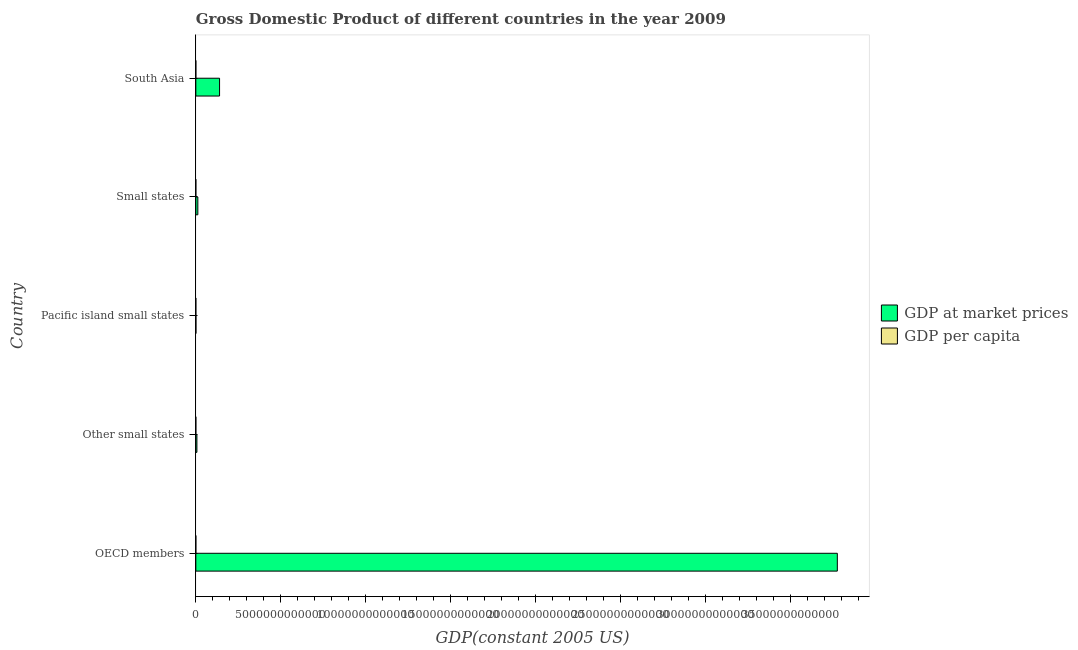How many different coloured bars are there?
Offer a terse response. 2. Are the number of bars per tick equal to the number of legend labels?
Your response must be concise. Yes. Are the number of bars on each tick of the Y-axis equal?
Offer a terse response. Yes. How many bars are there on the 1st tick from the bottom?
Keep it short and to the point. 2. What is the label of the 4th group of bars from the top?
Your answer should be compact. Other small states. What is the gdp per capita in Small states?
Give a very brief answer. 4236.76. Across all countries, what is the maximum gdp at market prices?
Ensure brevity in your answer.  3.77e+13. Across all countries, what is the minimum gdp per capita?
Give a very brief answer. 869.5. In which country was the gdp at market prices maximum?
Your answer should be very brief. OECD members. In which country was the gdp at market prices minimum?
Make the answer very short. Pacific island small states. What is the total gdp at market prices in the graph?
Your response must be concise. 3.93e+13. What is the difference between the gdp per capita in OECD members and that in Pacific island small states?
Offer a terse response. 2.81e+04. What is the difference between the gdp at market prices in OECD members and the gdp per capita in Other small states?
Your answer should be compact. 3.77e+13. What is the average gdp per capita per country?
Ensure brevity in your answer.  8305.46. What is the difference between the gdp per capita and gdp at market prices in Pacific island small states?
Give a very brief answer. -5.42e+09. What is the ratio of the gdp at market prices in Other small states to that in South Asia?
Make the answer very short. 0.04. Is the difference between the gdp per capita in OECD members and South Asia greater than the difference between the gdp at market prices in OECD members and South Asia?
Keep it short and to the point. No. What is the difference between the highest and the second highest gdp at market prices?
Keep it short and to the point. 3.64e+13. What is the difference between the highest and the lowest gdp per capita?
Ensure brevity in your answer.  2.97e+04. What does the 2nd bar from the top in OECD members represents?
Offer a very short reply. GDP at market prices. What does the 1st bar from the bottom in South Asia represents?
Your answer should be very brief. GDP at market prices. How many bars are there?
Keep it short and to the point. 10. Are all the bars in the graph horizontal?
Ensure brevity in your answer.  Yes. What is the difference between two consecutive major ticks on the X-axis?
Provide a short and direct response. 5.00e+12. Does the graph contain any zero values?
Offer a terse response. No. How are the legend labels stacked?
Your response must be concise. Vertical. What is the title of the graph?
Keep it short and to the point. Gross Domestic Product of different countries in the year 2009. Does "Infant" appear as one of the legend labels in the graph?
Your answer should be compact. No. What is the label or title of the X-axis?
Offer a very short reply. GDP(constant 2005 US). What is the GDP(constant 2005 US) in GDP at market prices in OECD members?
Make the answer very short. 3.77e+13. What is the GDP(constant 2005 US) of GDP per capita in OECD members?
Give a very brief answer. 3.06e+04. What is the GDP(constant 2005 US) of GDP at market prices in Other small states?
Your answer should be very brief. 6.30e+1. What is the GDP(constant 2005 US) of GDP per capita in Other small states?
Keep it short and to the point. 3317.46. What is the GDP(constant 2005 US) in GDP at market prices in Pacific island small states?
Provide a short and direct response. 5.42e+09. What is the GDP(constant 2005 US) in GDP per capita in Pacific island small states?
Ensure brevity in your answer.  2495.28. What is the GDP(constant 2005 US) in GDP at market prices in Small states?
Provide a short and direct response. 1.19e+11. What is the GDP(constant 2005 US) in GDP per capita in Small states?
Your answer should be very brief. 4236.76. What is the GDP(constant 2005 US) of GDP at market prices in South Asia?
Provide a short and direct response. 1.40e+12. What is the GDP(constant 2005 US) of GDP per capita in South Asia?
Offer a very short reply. 869.5. Across all countries, what is the maximum GDP(constant 2005 US) in GDP at market prices?
Make the answer very short. 3.77e+13. Across all countries, what is the maximum GDP(constant 2005 US) in GDP per capita?
Your response must be concise. 3.06e+04. Across all countries, what is the minimum GDP(constant 2005 US) of GDP at market prices?
Your answer should be very brief. 5.42e+09. Across all countries, what is the minimum GDP(constant 2005 US) of GDP per capita?
Offer a terse response. 869.5. What is the total GDP(constant 2005 US) of GDP at market prices in the graph?
Provide a short and direct response. 3.93e+13. What is the total GDP(constant 2005 US) of GDP per capita in the graph?
Your answer should be very brief. 4.15e+04. What is the difference between the GDP(constant 2005 US) in GDP at market prices in OECD members and that in Other small states?
Provide a succinct answer. 3.77e+13. What is the difference between the GDP(constant 2005 US) in GDP per capita in OECD members and that in Other small states?
Ensure brevity in your answer.  2.73e+04. What is the difference between the GDP(constant 2005 US) in GDP at market prices in OECD members and that in Pacific island small states?
Offer a very short reply. 3.77e+13. What is the difference between the GDP(constant 2005 US) of GDP per capita in OECD members and that in Pacific island small states?
Offer a terse response. 2.81e+04. What is the difference between the GDP(constant 2005 US) in GDP at market prices in OECD members and that in Small states?
Offer a terse response. 3.76e+13. What is the difference between the GDP(constant 2005 US) of GDP per capita in OECD members and that in Small states?
Give a very brief answer. 2.64e+04. What is the difference between the GDP(constant 2005 US) of GDP at market prices in OECD members and that in South Asia?
Offer a very short reply. 3.64e+13. What is the difference between the GDP(constant 2005 US) in GDP per capita in OECD members and that in South Asia?
Offer a terse response. 2.97e+04. What is the difference between the GDP(constant 2005 US) of GDP at market prices in Other small states and that in Pacific island small states?
Your response must be concise. 5.76e+1. What is the difference between the GDP(constant 2005 US) of GDP per capita in Other small states and that in Pacific island small states?
Your answer should be very brief. 822.18. What is the difference between the GDP(constant 2005 US) of GDP at market prices in Other small states and that in Small states?
Your answer should be compact. -5.55e+1. What is the difference between the GDP(constant 2005 US) of GDP per capita in Other small states and that in Small states?
Offer a very short reply. -919.3. What is the difference between the GDP(constant 2005 US) in GDP at market prices in Other small states and that in South Asia?
Ensure brevity in your answer.  -1.33e+12. What is the difference between the GDP(constant 2005 US) in GDP per capita in Other small states and that in South Asia?
Make the answer very short. 2447.96. What is the difference between the GDP(constant 2005 US) of GDP at market prices in Pacific island small states and that in Small states?
Give a very brief answer. -1.13e+11. What is the difference between the GDP(constant 2005 US) in GDP per capita in Pacific island small states and that in Small states?
Your answer should be very brief. -1741.47. What is the difference between the GDP(constant 2005 US) in GDP at market prices in Pacific island small states and that in South Asia?
Keep it short and to the point. -1.39e+12. What is the difference between the GDP(constant 2005 US) in GDP per capita in Pacific island small states and that in South Asia?
Provide a short and direct response. 1625.78. What is the difference between the GDP(constant 2005 US) in GDP at market prices in Small states and that in South Asia?
Your response must be concise. -1.28e+12. What is the difference between the GDP(constant 2005 US) of GDP per capita in Small states and that in South Asia?
Make the answer very short. 3367.26. What is the difference between the GDP(constant 2005 US) of GDP at market prices in OECD members and the GDP(constant 2005 US) of GDP per capita in Other small states?
Provide a succinct answer. 3.77e+13. What is the difference between the GDP(constant 2005 US) in GDP at market prices in OECD members and the GDP(constant 2005 US) in GDP per capita in Pacific island small states?
Offer a terse response. 3.77e+13. What is the difference between the GDP(constant 2005 US) in GDP at market prices in OECD members and the GDP(constant 2005 US) in GDP per capita in Small states?
Your response must be concise. 3.77e+13. What is the difference between the GDP(constant 2005 US) of GDP at market prices in OECD members and the GDP(constant 2005 US) of GDP per capita in South Asia?
Keep it short and to the point. 3.77e+13. What is the difference between the GDP(constant 2005 US) of GDP at market prices in Other small states and the GDP(constant 2005 US) of GDP per capita in Pacific island small states?
Your response must be concise. 6.30e+1. What is the difference between the GDP(constant 2005 US) in GDP at market prices in Other small states and the GDP(constant 2005 US) in GDP per capita in Small states?
Keep it short and to the point. 6.30e+1. What is the difference between the GDP(constant 2005 US) of GDP at market prices in Other small states and the GDP(constant 2005 US) of GDP per capita in South Asia?
Give a very brief answer. 6.30e+1. What is the difference between the GDP(constant 2005 US) in GDP at market prices in Pacific island small states and the GDP(constant 2005 US) in GDP per capita in Small states?
Give a very brief answer. 5.42e+09. What is the difference between the GDP(constant 2005 US) of GDP at market prices in Pacific island small states and the GDP(constant 2005 US) of GDP per capita in South Asia?
Ensure brevity in your answer.  5.42e+09. What is the difference between the GDP(constant 2005 US) in GDP at market prices in Small states and the GDP(constant 2005 US) in GDP per capita in South Asia?
Offer a very short reply. 1.19e+11. What is the average GDP(constant 2005 US) in GDP at market prices per country?
Offer a very short reply. 7.87e+12. What is the average GDP(constant 2005 US) of GDP per capita per country?
Give a very brief answer. 8305.46. What is the difference between the GDP(constant 2005 US) in GDP at market prices and GDP(constant 2005 US) in GDP per capita in OECD members?
Ensure brevity in your answer.  3.77e+13. What is the difference between the GDP(constant 2005 US) of GDP at market prices and GDP(constant 2005 US) of GDP per capita in Other small states?
Your answer should be very brief. 6.30e+1. What is the difference between the GDP(constant 2005 US) of GDP at market prices and GDP(constant 2005 US) of GDP per capita in Pacific island small states?
Your answer should be compact. 5.42e+09. What is the difference between the GDP(constant 2005 US) of GDP at market prices and GDP(constant 2005 US) of GDP per capita in Small states?
Keep it short and to the point. 1.19e+11. What is the difference between the GDP(constant 2005 US) of GDP at market prices and GDP(constant 2005 US) of GDP per capita in South Asia?
Provide a succinct answer. 1.40e+12. What is the ratio of the GDP(constant 2005 US) in GDP at market prices in OECD members to that in Other small states?
Offer a very short reply. 598.9. What is the ratio of the GDP(constant 2005 US) of GDP per capita in OECD members to that in Other small states?
Keep it short and to the point. 9.23. What is the ratio of the GDP(constant 2005 US) of GDP at market prices in OECD members to that in Pacific island small states?
Make the answer very short. 6963.17. What is the ratio of the GDP(constant 2005 US) in GDP per capita in OECD members to that in Pacific island small states?
Keep it short and to the point. 12.27. What is the ratio of the GDP(constant 2005 US) in GDP at market prices in OECD members to that in Small states?
Your answer should be compact. 318.4. What is the ratio of the GDP(constant 2005 US) of GDP per capita in OECD members to that in Small states?
Your answer should be compact. 7.22. What is the ratio of the GDP(constant 2005 US) in GDP at market prices in OECD members to that in South Asia?
Provide a succinct answer. 27.03. What is the ratio of the GDP(constant 2005 US) of GDP per capita in OECD members to that in South Asia?
Offer a terse response. 35.2. What is the ratio of the GDP(constant 2005 US) in GDP at market prices in Other small states to that in Pacific island small states?
Offer a very short reply. 11.63. What is the ratio of the GDP(constant 2005 US) in GDP per capita in Other small states to that in Pacific island small states?
Your answer should be very brief. 1.33. What is the ratio of the GDP(constant 2005 US) of GDP at market prices in Other small states to that in Small states?
Your answer should be compact. 0.53. What is the ratio of the GDP(constant 2005 US) in GDP per capita in Other small states to that in Small states?
Make the answer very short. 0.78. What is the ratio of the GDP(constant 2005 US) in GDP at market prices in Other small states to that in South Asia?
Offer a very short reply. 0.05. What is the ratio of the GDP(constant 2005 US) of GDP per capita in Other small states to that in South Asia?
Offer a very short reply. 3.82. What is the ratio of the GDP(constant 2005 US) in GDP at market prices in Pacific island small states to that in Small states?
Your response must be concise. 0.05. What is the ratio of the GDP(constant 2005 US) of GDP per capita in Pacific island small states to that in Small states?
Ensure brevity in your answer.  0.59. What is the ratio of the GDP(constant 2005 US) of GDP at market prices in Pacific island small states to that in South Asia?
Offer a terse response. 0. What is the ratio of the GDP(constant 2005 US) in GDP per capita in Pacific island small states to that in South Asia?
Offer a terse response. 2.87. What is the ratio of the GDP(constant 2005 US) in GDP at market prices in Small states to that in South Asia?
Make the answer very short. 0.08. What is the ratio of the GDP(constant 2005 US) in GDP per capita in Small states to that in South Asia?
Offer a terse response. 4.87. What is the difference between the highest and the second highest GDP(constant 2005 US) of GDP at market prices?
Your answer should be compact. 3.64e+13. What is the difference between the highest and the second highest GDP(constant 2005 US) in GDP per capita?
Your answer should be very brief. 2.64e+04. What is the difference between the highest and the lowest GDP(constant 2005 US) of GDP at market prices?
Provide a succinct answer. 3.77e+13. What is the difference between the highest and the lowest GDP(constant 2005 US) of GDP per capita?
Provide a succinct answer. 2.97e+04. 